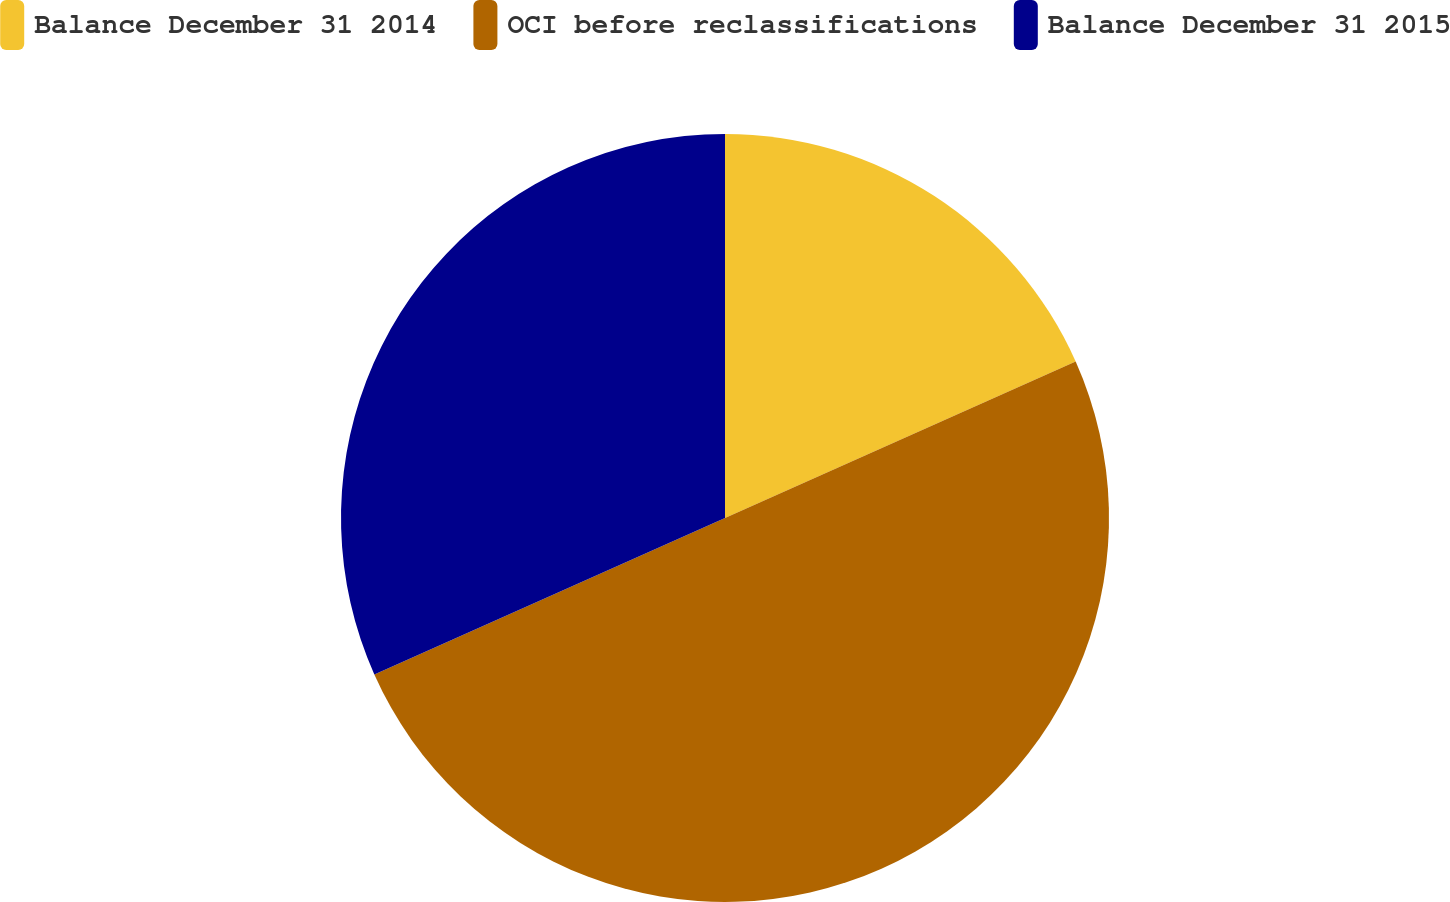Convert chart. <chart><loc_0><loc_0><loc_500><loc_500><pie_chart><fcel>Balance December 31 2014<fcel>OCI before reclassifications<fcel>Balance December 31 2015<nl><fcel>18.32%<fcel>50.0%<fcel>31.68%<nl></chart> 